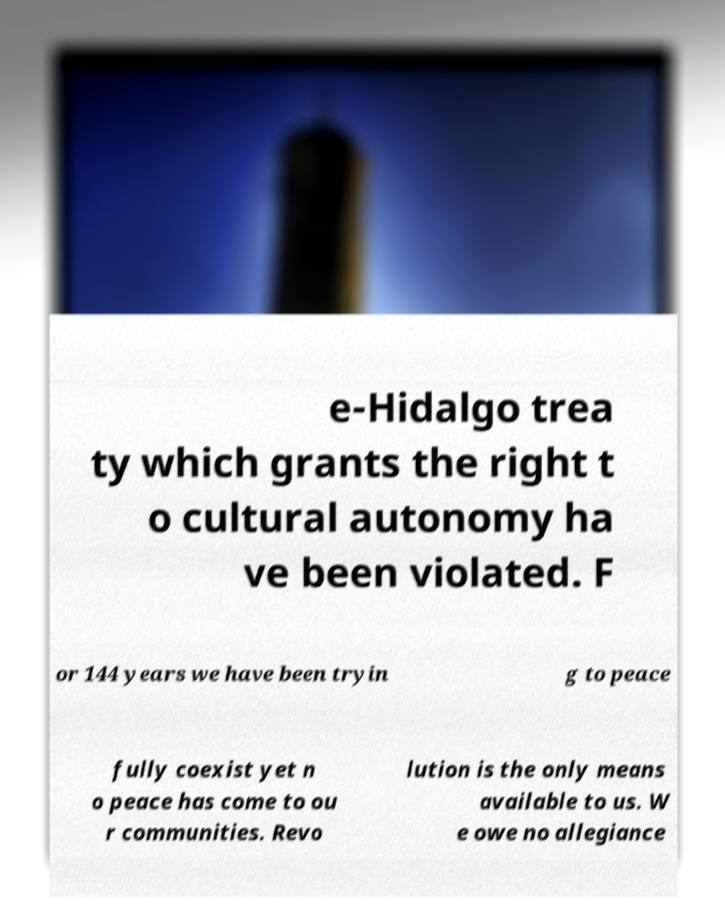Can you read and provide the text displayed in the image?This photo seems to have some interesting text. Can you extract and type it out for me? e-Hidalgo trea ty which grants the right t o cultural autonomy ha ve been violated. F or 144 years we have been tryin g to peace fully coexist yet n o peace has come to ou r communities. Revo lution is the only means available to us. W e owe no allegiance 